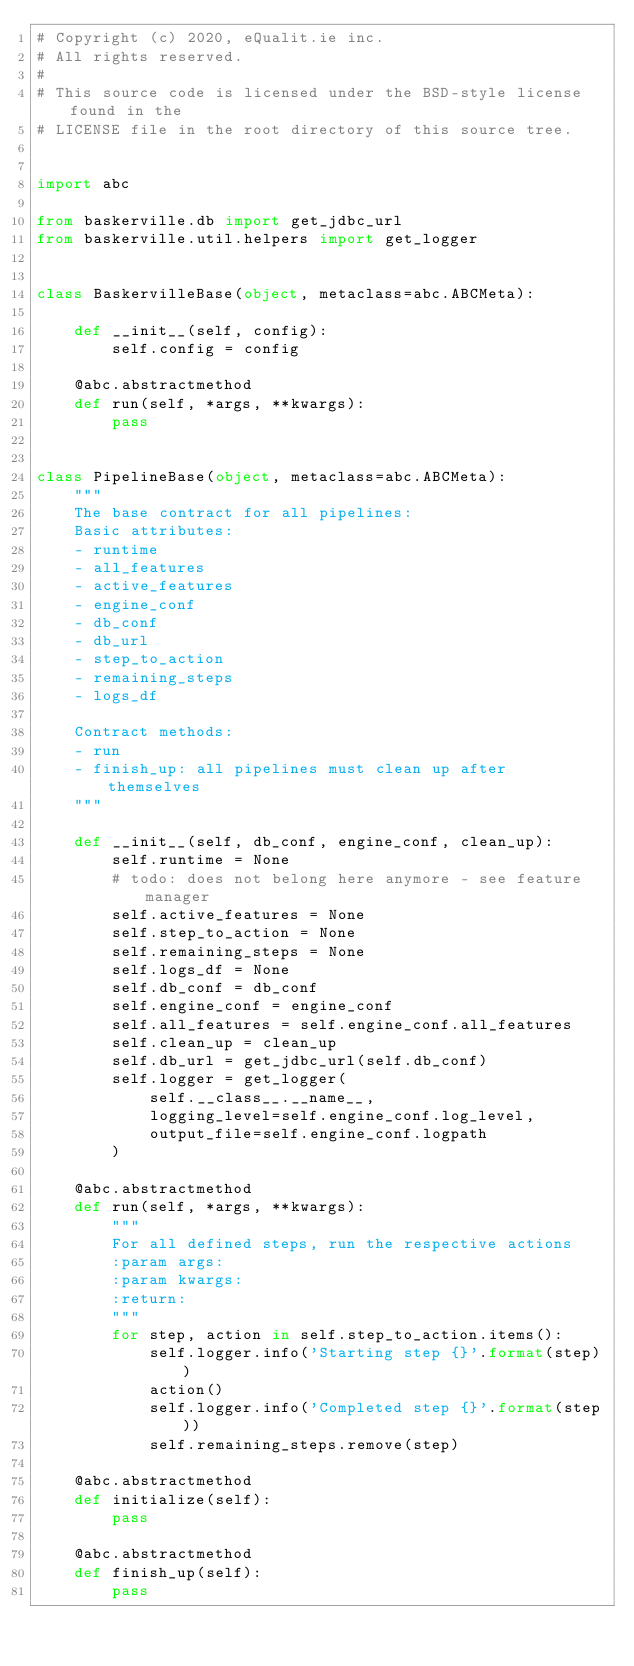Convert code to text. <code><loc_0><loc_0><loc_500><loc_500><_Python_># Copyright (c) 2020, eQualit.ie inc.
# All rights reserved.
#
# This source code is licensed under the BSD-style license found in the
# LICENSE file in the root directory of this source tree.


import abc

from baskerville.db import get_jdbc_url
from baskerville.util.helpers import get_logger


class BaskervilleBase(object, metaclass=abc.ABCMeta):

    def __init__(self, config):
        self.config = config

    @abc.abstractmethod
    def run(self, *args, **kwargs):
        pass


class PipelineBase(object, metaclass=abc.ABCMeta):
    """
    The base contract for all pipelines:
    Basic attributes:
    - runtime
    - all_features
    - active_features
    - engine_conf
    - db_conf
    - db_url
    - step_to_action
    - remaining_steps
    - logs_df

    Contract methods:
    - run
    - finish_up: all pipelines must clean up after themselves
    """

    def __init__(self, db_conf, engine_conf, clean_up):
        self.runtime = None
        # todo: does not belong here anymore - see feature manager
        self.active_features = None
        self.step_to_action = None
        self.remaining_steps = None
        self.logs_df = None
        self.db_conf = db_conf
        self.engine_conf = engine_conf
        self.all_features = self.engine_conf.all_features
        self.clean_up = clean_up
        self.db_url = get_jdbc_url(self.db_conf)
        self.logger = get_logger(
            self.__class__.__name__,
            logging_level=self.engine_conf.log_level,
            output_file=self.engine_conf.logpath
        )

    @abc.abstractmethod
    def run(self, *args, **kwargs):
        """
        For all defined steps, run the respective actions
        :param args:
        :param kwargs:
        :return:
        """
        for step, action in self.step_to_action.items():
            self.logger.info('Starting step {}'.format(step))
            action()
            self.logger.info('Completed step {}'.format(step))
            self.remaining_steps.remove(step)

    @abc.abstractmethod
    def initialize(self):
        pass

    @abc.abstractmethod
    def finish_up(self):
        pass
</code> 